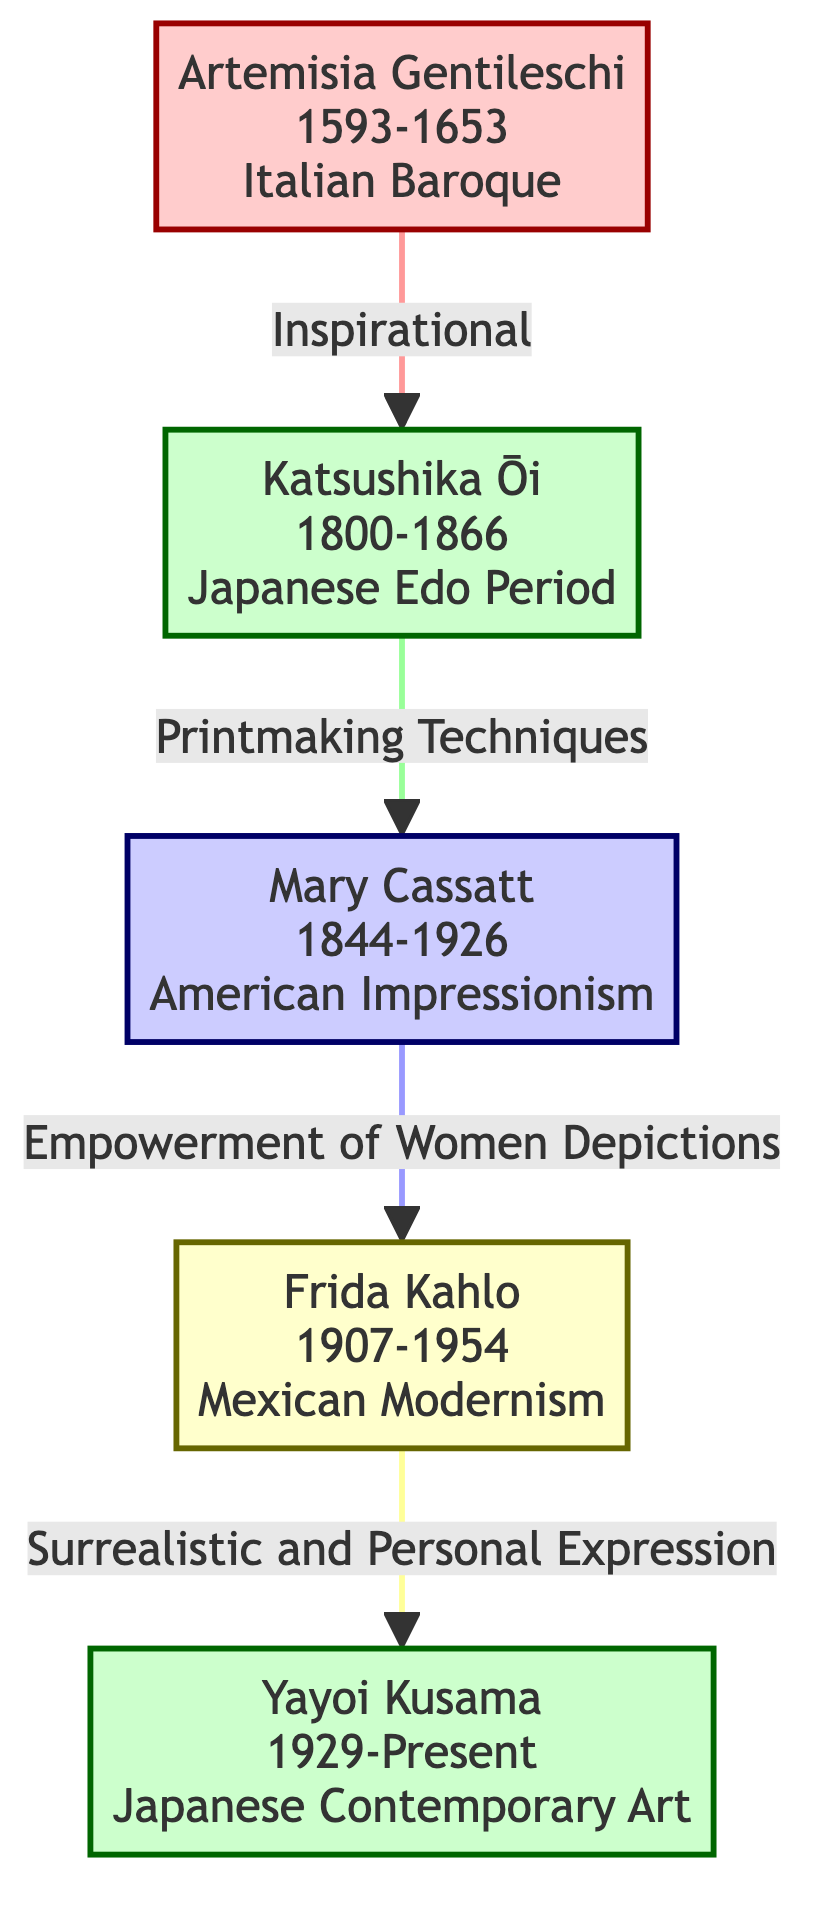What is the birth year of Artemisia Gentileschi? The diagram shows "Artemisia Gentileschi" with the birth year listed as "1593". Therefore, we can directly take this information from the node.
Answer: 1593 What genre did Mary Cassatt primarily work in? Looking at the "Mary Cassatt" node, it lists the genres she worked in as "Impressionism" and "Portraiture". Since the question is looking for primary genre, we can say "Impressionism" since it is more prominent in her contributions.
Answer: Impressionism How many women are represented in this family tree? There are five nodes shown in the diagram: "Artemisia Gentileschi", "Katsushika Ōi", "Mary Cassatt", "Frida Kahlo", and "Yayoi Kusama". Thus, counting the nodes gives us the total number.
Answer: 5 What is the relationship between Frida Kahlo and Yayoi Kusama? The diagram specifies a direct connection with the relationship labeled as "Surrealistic and Personal Expression" between "Frida Kahlo" and "Yayoi Kusama". This is explicitly stated along the connecting line.
Answer: Surrealistic and Personal Expression Who is listed as an influence on Katsushika Ōi? In the nodes for Katsushika Ōi, it lists "Katsushika Hokusai" as her influence. This information is explicitly presented under her node.
Answer: Katsushika Hokusai Which artist is connected to both Artemisia Gentileschi and Mary Cassatt? To answer this, we have to look at the relationships. "Katsushika Ōi" is connected to "Artemisia Gentileschi" and also connected to "Mary Cassatt". Therefore, "Katsushika Ōi" is the common connection.
Answer: Katsushika Ōi What year did Frida Kahlo pass away? The diagram lists "Frida Kahlo" with a death year of "1954". This information can be directly retrieved from her node.
Answer: 1954 What artistic style influenced Yayoi Kusama? The node for "Yayoi Kusama" lists influences as "Abstract Expressionism" and "Minimalism". Thus, both styles influenced her, but we can mention the first one here for a concise answer.
Answer: Abstract Expressionism How does Mary Cassatt relate to the empowerment of women? The diagram shows a direct relationship labeled "Empowerment of Women Depictions" connecting "Mary Cassatt" to "Frida Kahlo". This highlights her contributions to women's empowerment through her art.
Answer: Empowerment of Women Depictions 